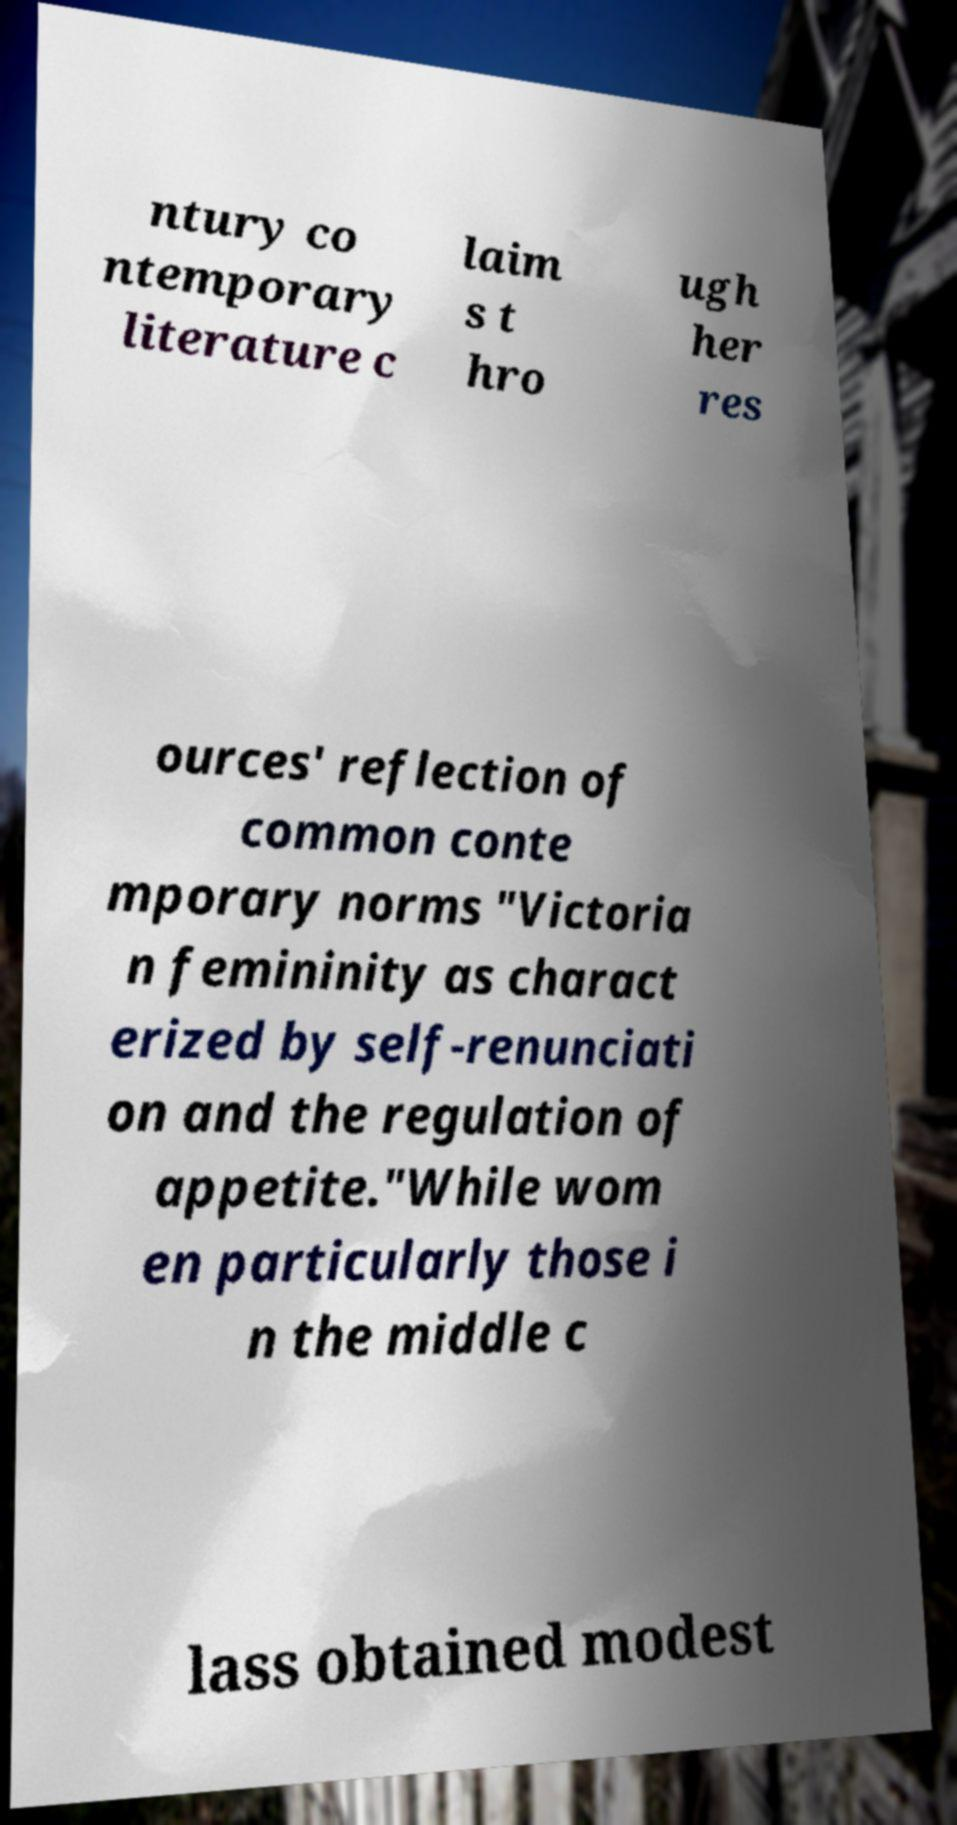Please identify and transcribe the text found in this image. ntury co ntemporary literature c laim s t hro ugh her res ources' reflection of common conte mporary norms "Victoria n femininity as charact erized by self-renunciati on and the regulation of appetite."While wom en particularly those i n the middle c lass obtained modest 